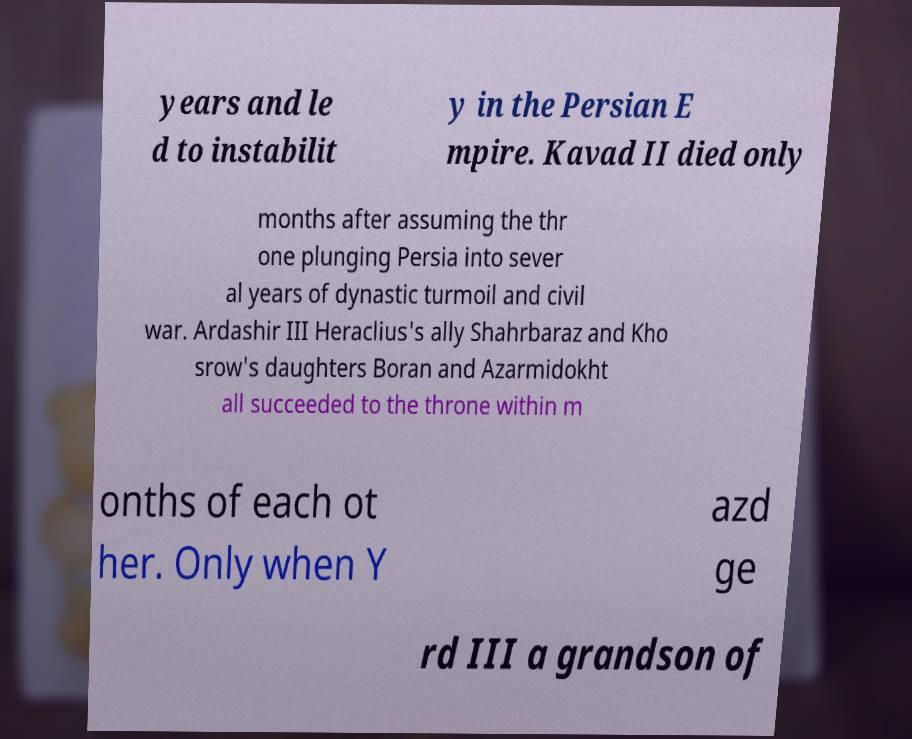Please read and relay the text visible in this image. What does it say? years and le d to instabilit y in the Persian E mpire. Kavad II died only months after assuming the thr one plunging Persia into sever al years of dynastic turmoil and civil war. Ardashir III Heraclius's ally Shahrbaraz and Kho srow's daughters Boran and Azarmidokht all succeeded to the throne within m onths of each ot her. Only when Y azd ge rd III a grandson of 